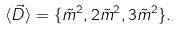Convert formula to latex. <formula><loc_0><loc_0><loc_500><loc_500>\langle { \vec { D } } \rangle = \{ \tilde { m } ^ { 2 } , 2 \tilde { m } ^ { 2 } , 3 \tilde { m } ^ { 2 } \} .</formula> 